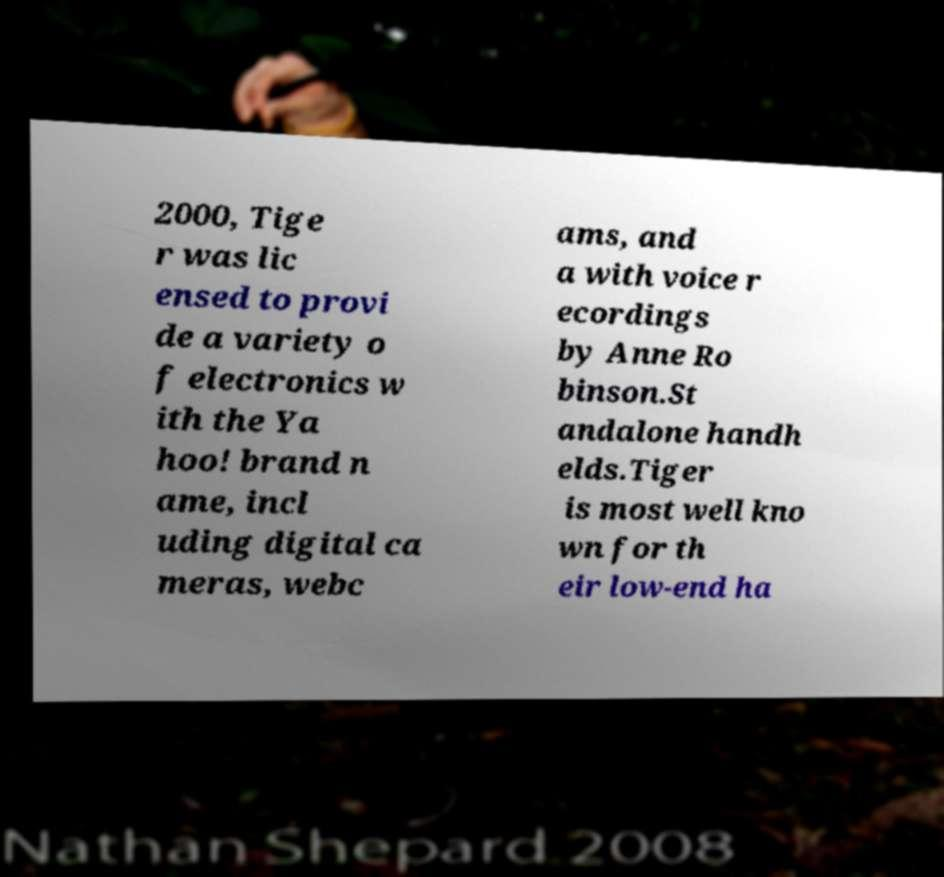I need the written content from this picture converted into text. Can you do that? 2000, Tige r was lic ensed to provi de a variety o f electronics w ith the Ya hoo! brand n ame, incl uding digital ca meras, webc ams, and a with voice r ecordings by Anne Ro binson.St andalone handh elds.Tiger is most well kno wn for th eir low-end ha 